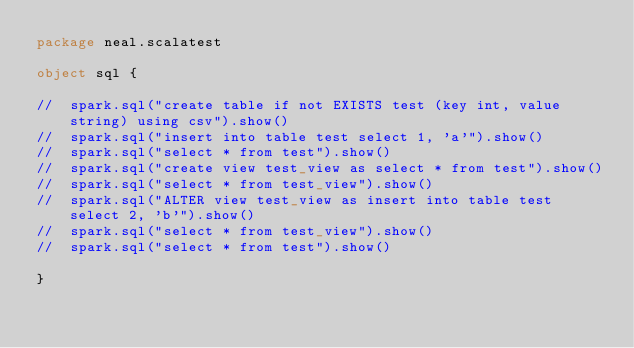Convert code to text. <code><loc_0><loc_0><loc_500><loc_500><_Scala_>package neal.scalatest

object sql {

//  spark.sql("create table if not EXISTS test (key int, value string) using csv").show()
//  spark.sql("insert into table test select 1, 'a'").show()
//  spark.sql("select * from test").show()
//  spark.sql("create view test_view as select * from test").show()
//  spark.sql("select * from test_view").show()
//  spark.sql("ALTER view test_view as insert into table test select 2, 'b'").show()
//  spark.sql("select * from test_view").show()
//  spark.sql("select * from test").show()

}
</code> 